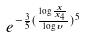Convert formula to latex. <formula><loc_0><loc_0><loc_500><loc_500>e ^ { - \frac { 3 } { 5 } ( \frac { \log \frac { x } { x _ { 4 } } } { \log \upsilon } ) ^ { 5 } }</formula> 